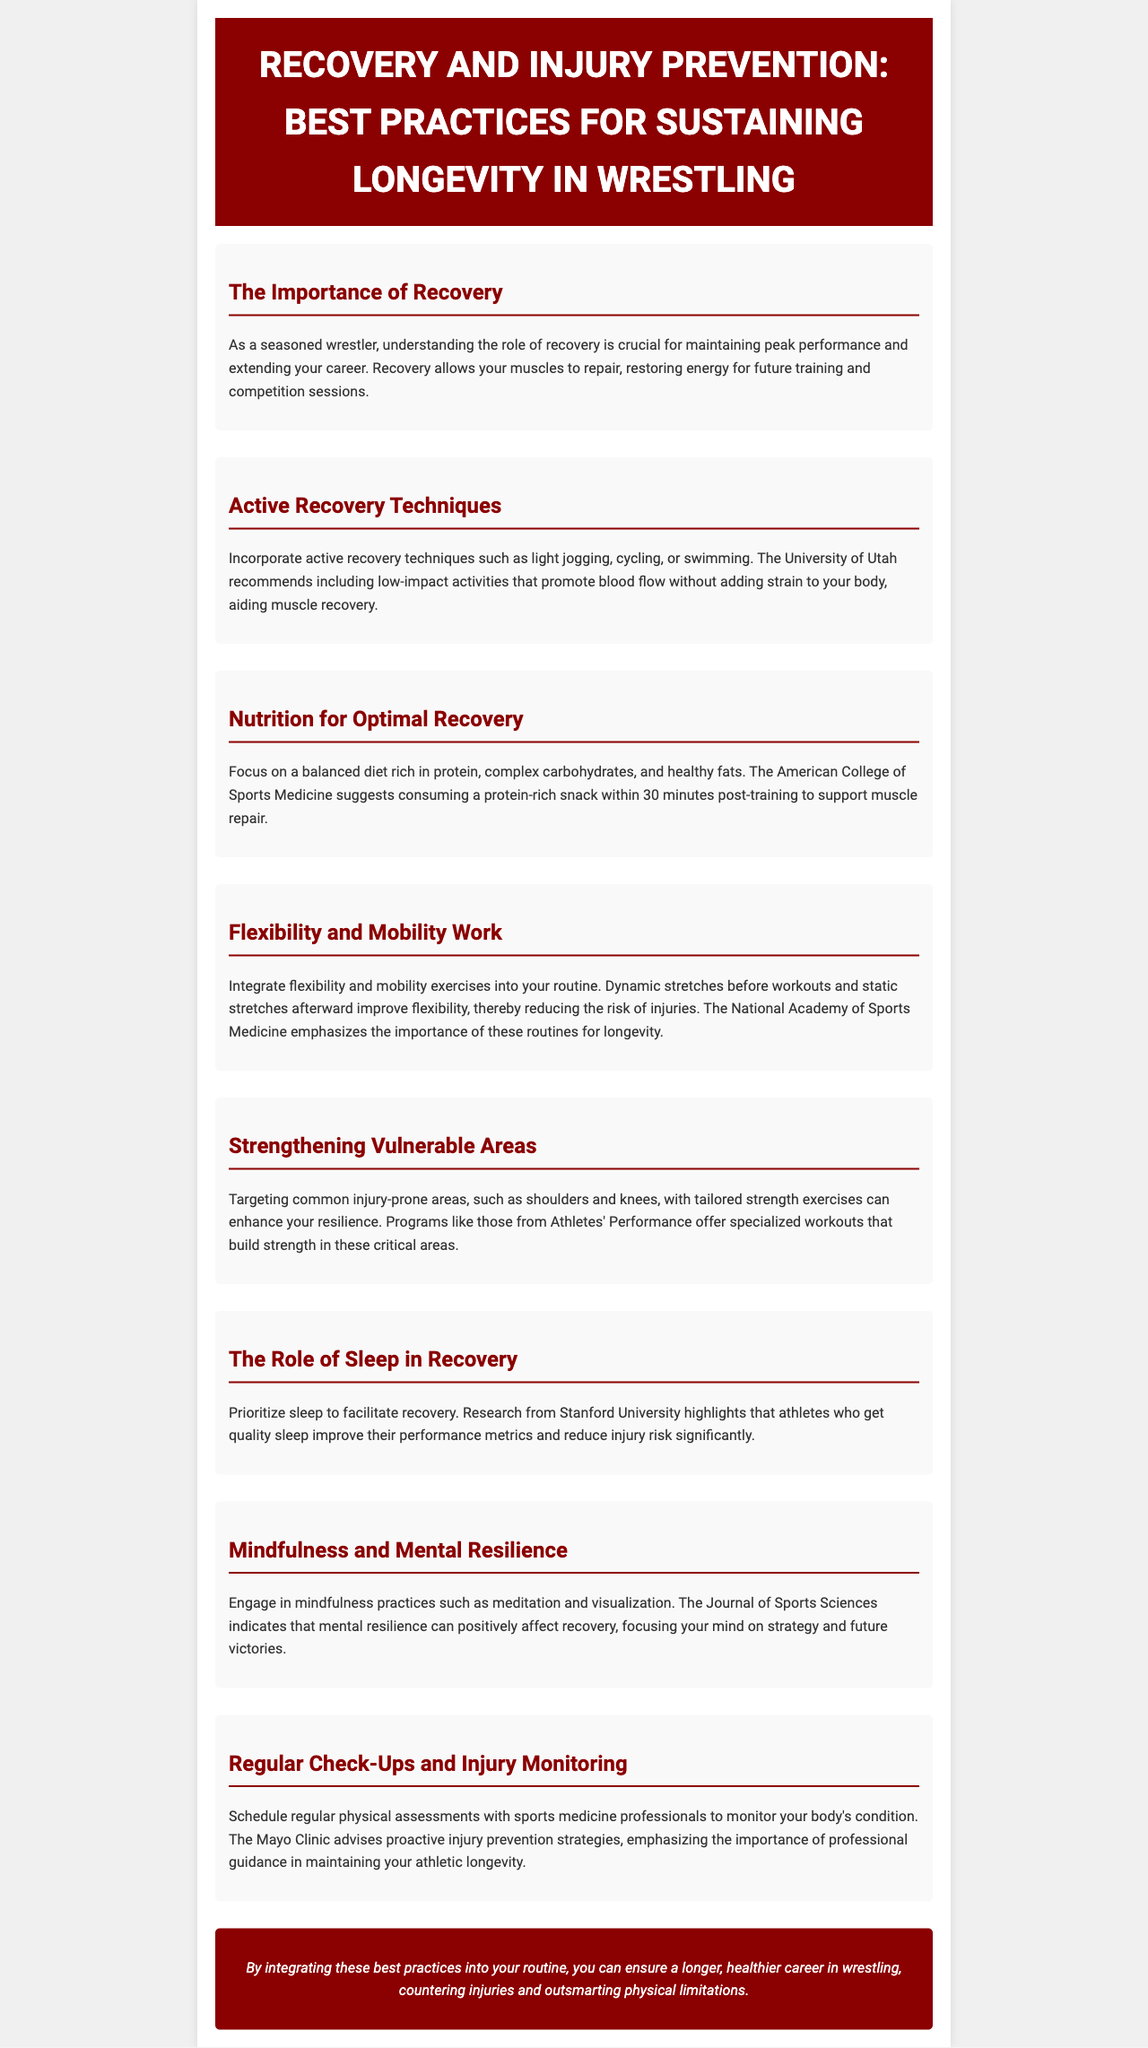What is the title of the newsletter? The title of the newsletter is found in the header section of the document.
Answer: Recovery and Injury Prevention: Best Practices for Sustaining Longevity in Wrestling What is a recommended active recovery technique? The document offers various active recovery techniques, one of which is specified.
Answer: Cycling What should be consumed within 30 minutes post-training? The newsletter provides nutritional advice, specifically mentioning a type of snack to consume post-training.
Answer: Protein-rich snack Which organization emphasizes flexibility routines? The document attributes a specific recommendation about flexibility and mobility exercises to an organization.
Answer: National Academy of Sports Medicine What is highlighted as important for improving performance metrics? The document discusses a factor essential for enhancing performance and its role in recovery.
Answer: Quality sleep Which technique is recommended for building mental resilience? The newsletter lists specific practices that can improve mental resilience, one of which is mentioned.
Answer: Meditation What is a key strategy for injury prevention mentioned in the document? The newsletter discusses a proactive approach recommended by a clinical institution for injury prevention.
Answer: Regular check-ups Which areas should be strengthened to avoid injuries? The document specifies certain areas of the body that are prone to injury and need strengthening.
Answer: Shoulders and knees 